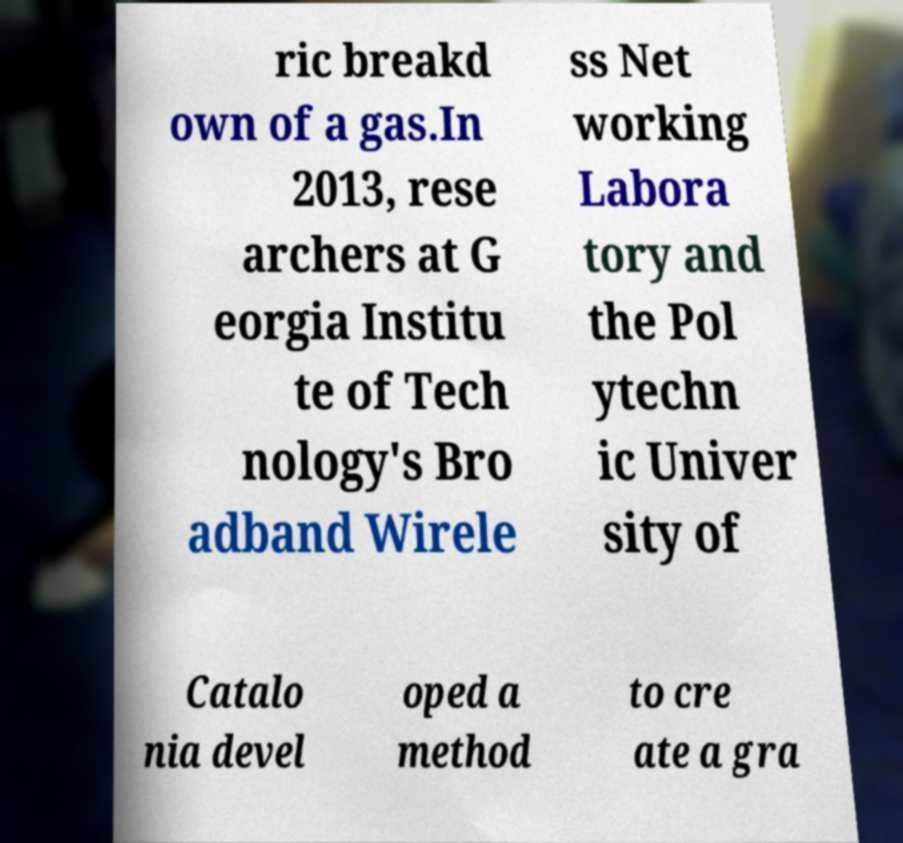What messages or text are displayed in this image? I need them in a readable, typed format. ric breakd own of a gas.In 2013, rese archers at G eorgia Institu te of Tech nology's Bro adband Wirele ss Net working Labora tory and the Pol ytechn ic Univer sity of Catalo nia devel oped a method to cre ate a gra 